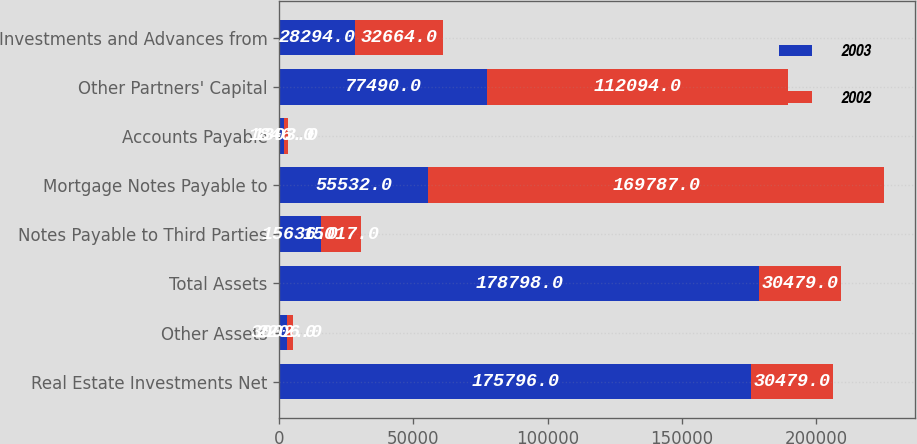Convert chart to OTSL. <chart><loc_0><loc_0><loc_500><loc_500><stacked_bar_chart><ecel><fcel>Real Estate Investments Net<fcel>Other Assets<fcel>Total Assets<fcel>Notes Payable to Third Parties<fcel>Mortgage Notes Payable to<fcel>Accounts Payable<fcel>Other Partners' Capital<fcel>Investments and Advances from<nl><fcel>2003<fcel>175796<fcel>3002<fcel>178798<fcel>15636<fcel>55532<fcel>1846<fcel>77490<fcel>28294<nl><fcel>2002<fcel>30479<fcel>2206<fcel>30479<fcel>15017<fcel>169787<fcel>1303<fcel>112094<fcel>32664<nl></chart> 